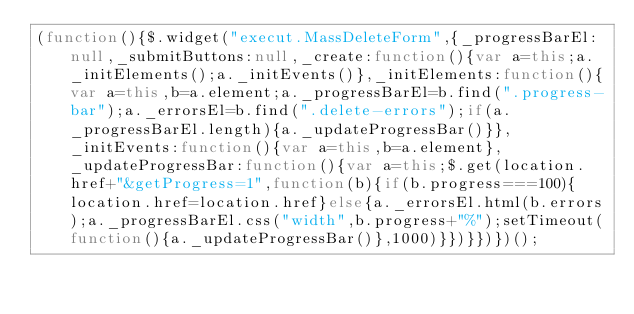Convert code to text. <code><loc_0><loc_0><loc_500><loc_500><_JavaScript_>(function(){$.widget("execut.MassDeleteForm",{_progressBarEl:null,_submitButtons:null,_create:function(){var a=this;a._initElements();a._initEvents()},_initElements:function(){var a=this,b=a.element;a._progressBarEl=b.find(".progress-bar");a._errorsEl=b.find(".delete-errors");if(a._progressBarEl.length){a._updateProgressBar()}},_initEvents:function(){var a=this,b=a.element},_updateProgressBar:function(){var a=this;$.get(location.href+"&getProgress=1",function(b){if(b.progress===100){location.href=location.href}else{a._errorsEl.html(b.errors);a._progressBarEl.css("width",b.progress+"%");setTimeout(function(){a._updateProgressBar()},1000)}})}})})();</code> 